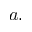Convert formula to latex. <formula><loc_0><loc_0><loc_500><loc_500>a .</formula> 